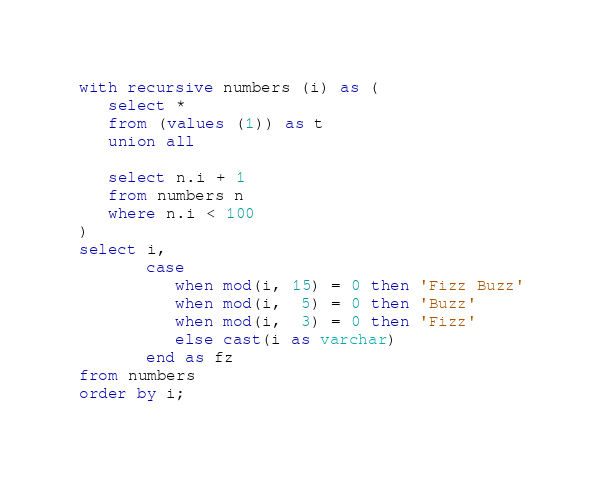<code> <loc_0><loc_0><loc_500><loc_500><_SQL_>with recursive numbers (i) as (
   select *
   from (values (1)) as t
   union all
   
   select n.i + 1
   from numbers n
   where n.i < 100
)
select i,
       case 
          when mod(i, 15) = 0 then 'Fizz Buzz'
          when mod(i,  5) = 0 then 'Buzz'
          when mod(i,  3) = 0 then 'Fizz'
          else cast(i as varchar)
       end as fz
from numbers 
order by i;</code> 